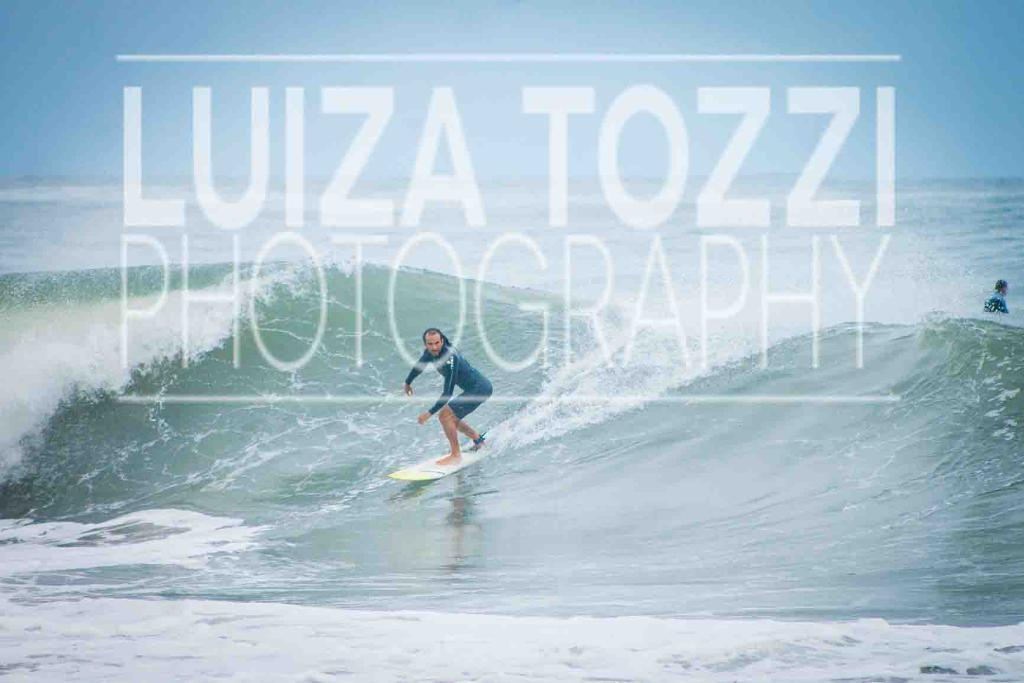What is the primary element in the image? There is water in the image. Are there any people present in the image? Yes, there are people in the image. What activity is one of the people engaged in? One person is surfing in the water. Can you describe any additional features of the image? There is a watermark on the image. What type of religious attraction can be seen in the image? There is no religious attraction present in the image; it features water and people, with one person surfing. 